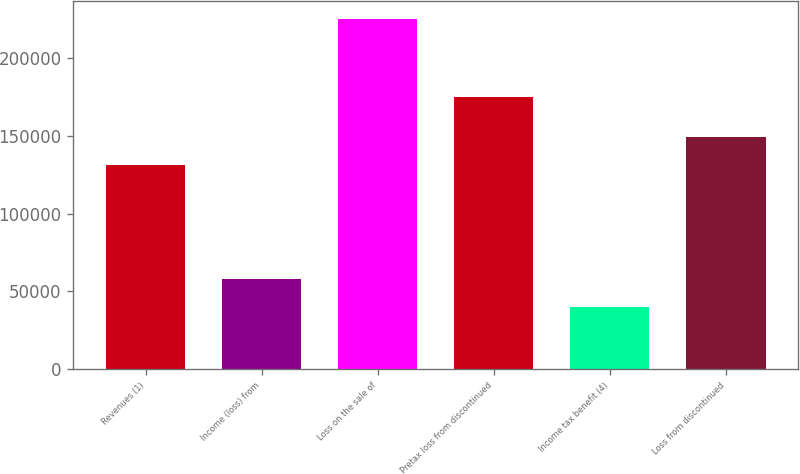Convert chart. <chart><loc_0><loc_0><loc_500><loc_500><bar_chart><fcel>Revenues (1)<fcel>Income (loss) from<fcel>Loss on the sale of<fcel>Pretax loss from discontinued<fcel>Income tax benefit (4)<fcel>Loss from discontinued<nl><fcel>130935<fcel>58187.8<fcel>225289<fcel>174784<fcel>39621<fcel>149502<nl></chart> 